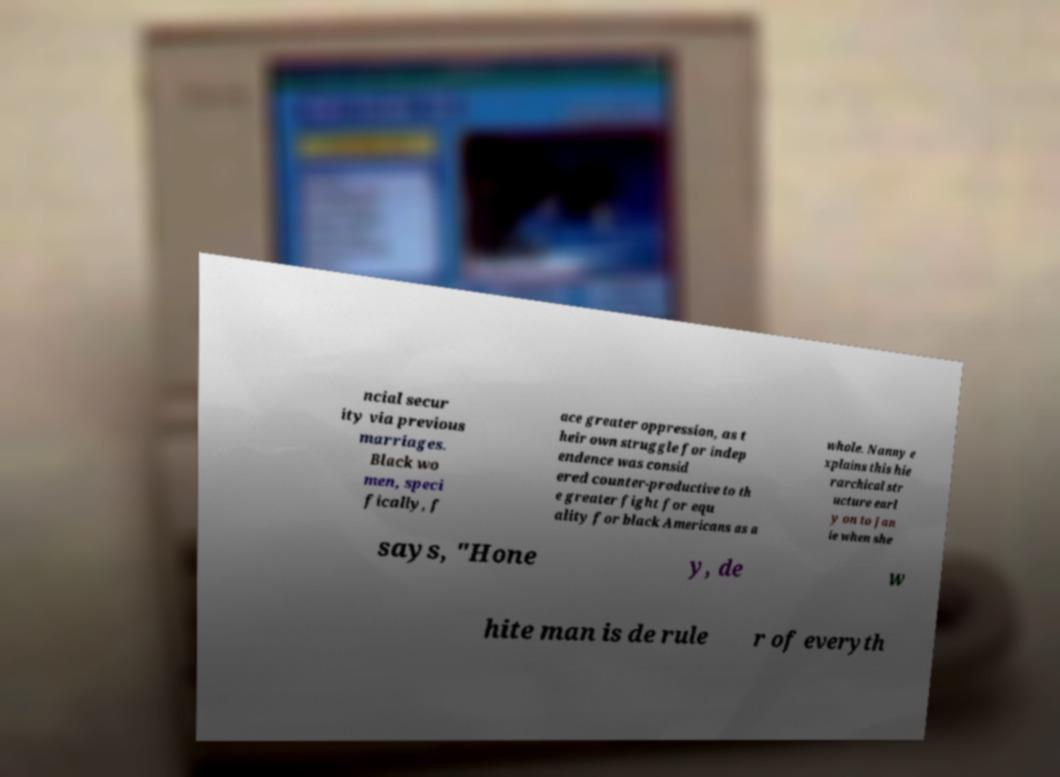Can you read and provide the text displayed in the image?This photo seems to have some interesting text. Can you extract and type it out for me? ncial secur ity via previous marriages. Black wo men, speci fically, f ace greater oppression, as t heir own struggle for indep endence was consid ered counter-productive to th e greater fight for equ ality for black Americans as a whole. Nanny e xplains this hie rarchical str ucture earl y on to Jan ie when she says, "Hone y, de w hite man is de rule r of everyth 